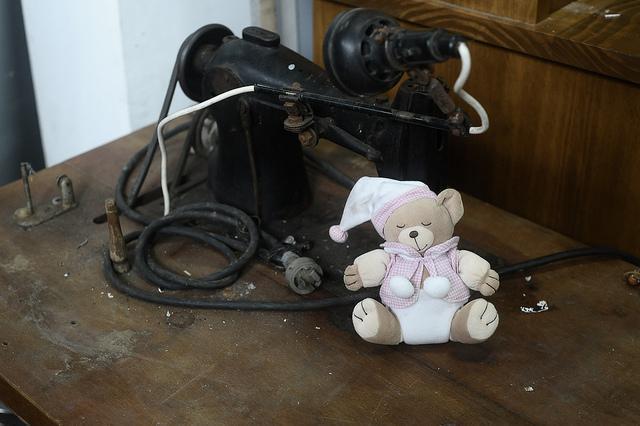Is "The dining table is next to the teddy bear." an appropriate description for the image?
Answer yes or no. No. 